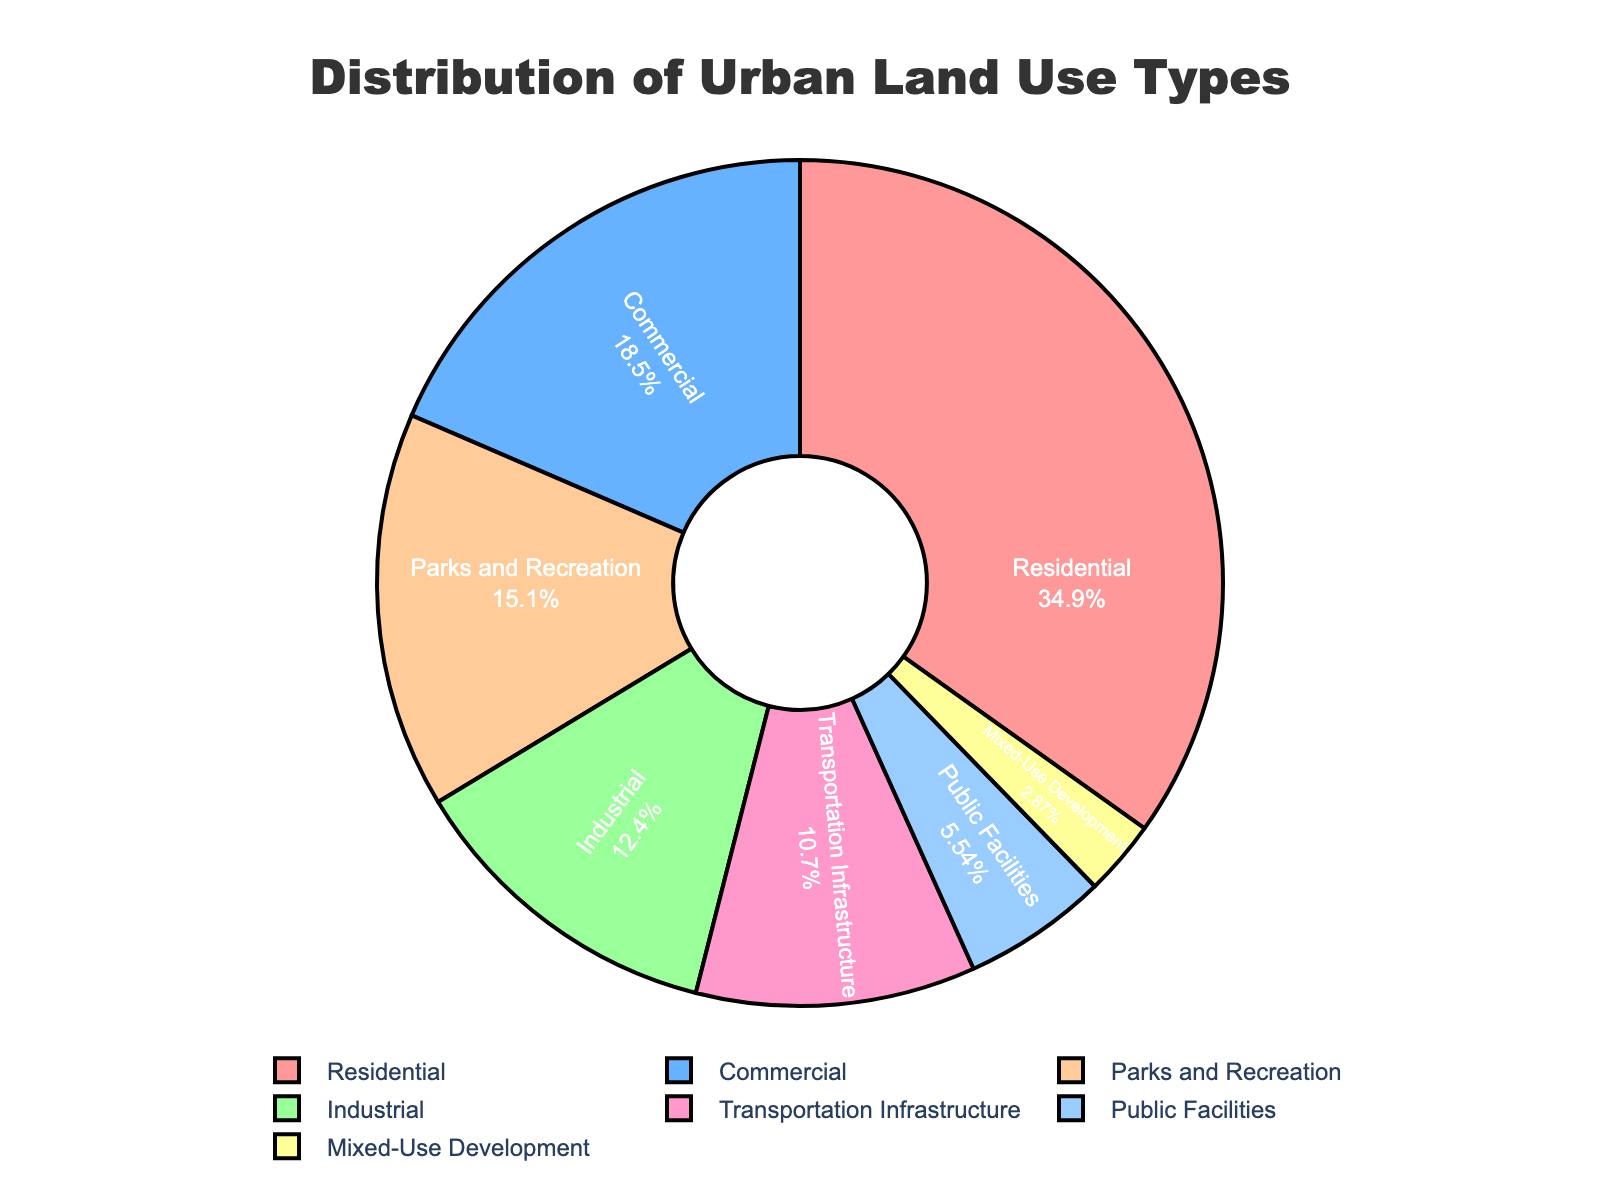What percentage of the land is used for residential purposes? The figure shows that the residential area takes up 35.2% of the total urban land use.
Answer: 35.2% Which land use type occupies the smallest percentage of the area? By looking at the sections of the pie chart and their associated percentages, Mixed-Use Development occupies the smallest portion with 2.9%.
Answer: Mixed-Use Development How much more land is used for commercial purposes than for public facilities? To find out the difference, subtract the percentage of public facilities from the percentage of commercial land use: 18.7% - 5.6% = 13.1%.
Answer: 13.1% What are the total percentages of land used for parks and recreation, and transportation infrastructure? Add the percentages of parks and recreation (15.3%) and transportation infrastructure (10.8%): 15.3% + 10.8% = 26.1%.
Answer: 26.1% Compare the combined percentage of commercial and industrial land use to residential land use. Which is greater? Add the percentages of commercial (18.7%) and industrial (12.5%) land use: 18.7% + 12.5% = 31.2%. Compare this to residential land use (35.2%). Residential land use is greater.
Answer: Residential land use Which two land use types have the closest percentages? By examining the pie chart, the percentages for Parks and Recreation (15.3%) and Transportation Infrastructure (10.8%) are the closest to each other. The difference is 15.3% - 10.8% = 4.5%.
Answer: Parks and Recreation and Transportation Infrastructure What is the second most common land use type? The pie chart shows that the second largest slice after residential (35.2%) is commercial, which occupies 18.7% of the land.
Answer: Commercial Calculate the average percentage of land use for public facilities, parks and recreation, and industrial areas. To get the average percentage, add the three values: 5.6% (public facilities) + 15.3% (parks and recreation) + 12.5% (industrial) = 33.4%, then divide by 3: 33.4% / 3 = 11.13%.
Answer: 11.13% What color represents transportation infrastructure on the pie chart? By looking at the visual attributes of the chart, transportation infrastructure is represented by the blue color.
Answer: Blue Which land use types together make up more than 50% of the total land use? Evaluating the pie chart, we can see that residential (35.2%) and commercial (18.7%) together make up more than 50% (35.2% + 18.7% = 53.9%).
Answer: Residential and Commercial 